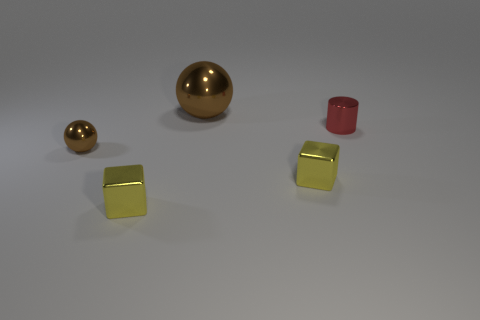What material seems to be depicted for the objects on the left? The objects on the left appear to be rendered with a metallic finish, possibly representing materials like brass or gold, characterized by their shiny, reflective surface. 